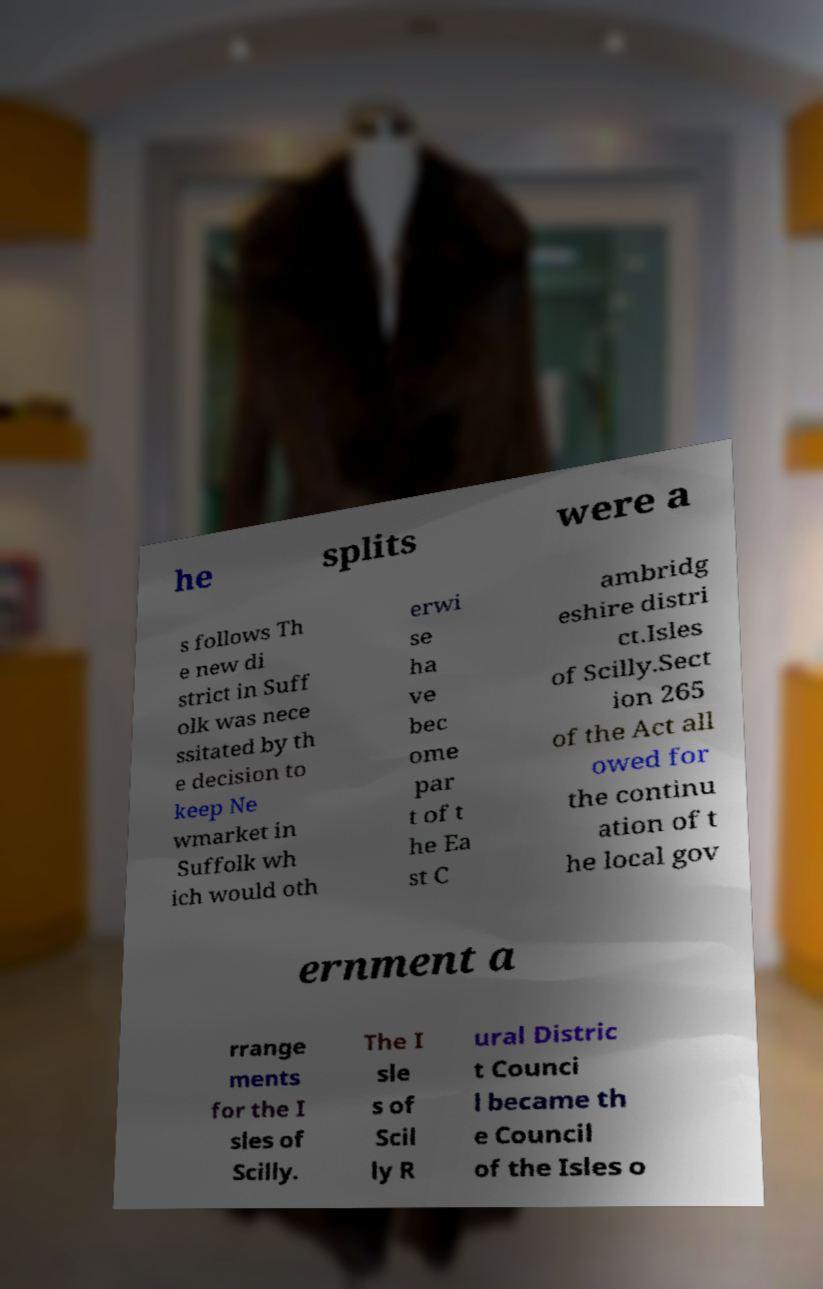What messages or text are displayed in this image? I need them in a readable, typed format. he splits were a s follows Th e new di strict in Suff olk was nece ssitated by th e decision to keep Ne wmarket in Suffolk wh ich would oth erwi se ha ve bec ome par t of t he Ea st C ambridg eshire distri ct.Isles of Scilly.Sect ion 265 of the Act all owed for the continu ation of t he local gov ernment a rrange ments for the I sles of Scilly. The I sle s of Scil ly R ural Distric t Counci l became th e Council of the Isles o 